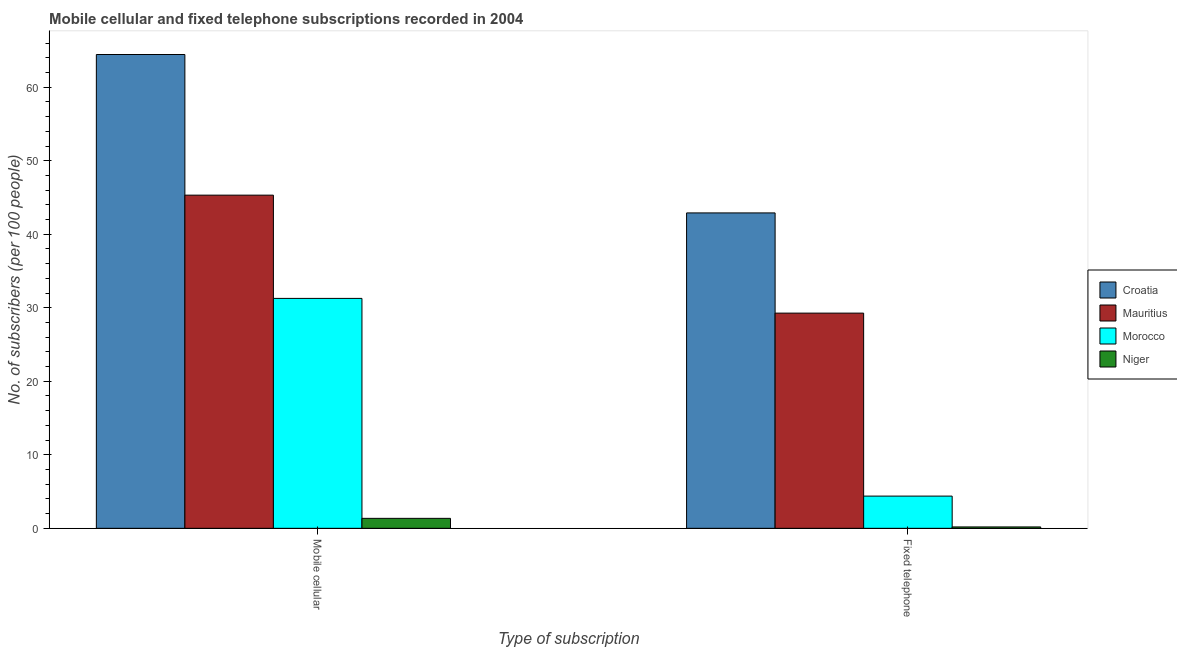How many groups of bars are there?
Your response must be concise. 2. Are the number of bars per tick equal to the number of legend labels?
Your response must be concise. Yes. How many bars are there on the 1st tick from the right?
Keep it short and to the point. 4. What is the label of the 2nd group of bars from the left?
Make the answer very short. Fixed telephone. What is the number of mobile cellular subscribers in Croatia?
Provide a short and direct response. 64.45. Across all countries, what is the maximum number of fixed telephone subscribers?
Provide a short and direct response. 42.9. Across all countries, what is the minimum number of fixed telephone subscribers?
Your answer should be compact. 0.19. In which country was the number of mobile cellular subscribers maximum?
Provide a short and direct response. Croatia. In which country was the number of fixed telephone subscribers minimum?
Your answer should be compact. Niger. What is the total number of fixed telephone subscribers in the graph?
Ensure brevity in your answer.  76.75. What is the difference between the number of fixed telephone subscribers in Croatia and that in Niger?
Your answer should be compact. 42.71. What is the difference between the number of fixed telephone subscribers in Croatia and the number of mobile cellular subscribers in Niger?
Keep it short and to the point. 41.55. What is the average number of fixed telephone subscribers per country?
Provide a short and direct response. 19.19. What is the difference between the number of fixed telephone subscribers and number of mobile cellular subscribers in Croatia?
Make the answer very short. -21.54. In how many countries, is the number of mobile cellular subscribers greater than 58 ?
Provide a succinct answer. 1. What is the ratio of the number of mobile cellular subscribers in Niger to that in Morocco?
Make the answer very short. 0.04. Is the number of mobile cellular subscribers in Croatia less than that in Niger?
Your answer should be very brief. No. What does the 1st bar from the left in Fixed telephone represents?
Make the answer very short. Croatia. What does the 3rd bar from the right in Fixed telephone represents?
Ensure brevity in your answer.  Mauritius. How many bars are there?
Offer a terse response. 8. How many countries are there in the graph?
Ensure brevity in your answer.  4. Are the values on the major ticks of Y-axis written in scientific E-notation?
Offer a very short reply. No. Does the graph contain any zero values?
Offer a terse response. No. What is the title of the graph?
Your answer should be very brief. Mobile cellular and fixed telephone subscriptions recorded in 2004. What is the label or title of the X-axis?
Provide a succinct answer. Type of subscription. What is the label or title of the Y-axis?
Ensure brevity in your answer.  No. of subscribers (per 100 people). What is the No. of subscribers (per 100 people) in Croatia in Mobile cellular?
Your answer should be compact. 64.45. What is the No. of subscribers (per 100 people) in Mauritius in Mobile cellular?
Ensure brevity in your answer.  45.32. What is the No. of subscribers (per 100 people) of Morocco in Mobile cellular?
Keep it short and to the point. 31.27. What is the No. of subscribers (per 100 people) in Niger in Mobile cellular?
Ensure brevity in your answer.  1.36. What is the No. of subscribers (per 100 people) in Croatia in Fixed telephone?
Keep it short and to the point. 42.9. What is the No. of subscribers (per 100 people) in Mauritius in Fixed telephone?
Give a very brief answer. 29.27. What is the No. of subscribers (per 100 people) in Morocco in Fixed telephone?
Your response must be concise. 4.38. What is the No. of subscribers (per 100 people) in Niger in Fixed telephone?
Give a very brief answer. 0.19. Across all Type of subscription, what is the maximum No. of subscribers (per 100 people) in Croatia?
Your answer should be very brief. 64.45. Across all Type of subscription, what is the maximum No. of subscribers (per 100 people) of Mauritius?
Your answer should be very brief. 45.32. Across all Type of subscription, what is the maximum No. of subscribers (per 100 people) in Morocco?
Keep it short and to the point. 31.27. Across all Type of subscription, what is the maximum No. of subscribers (per 100 people) of Niger?
Your answer should be compact. 1.36. Across all Type of subscription, what is the minimum No. of subscribers (per 100 people) in Croatia?
Make the answer very short. 42.9. Across all Type of subscription, what is the minimum No. of subscribers (per 100 people) of Mauritius?
Offer a very short reply. 29.27. Across all Type of subscription, what is the minimum No. of subscribers (per 100 people) in Morocco?
Provide a short and direct response. 4.38. Across all Type of subscription, what is the minimum No. of subscribers (per 100 people) of Niger?
Make the answer very short. 0.19. What is the total No. of subscribers (per 100 people) of Croatia in the graph?
Provide a succinct answer. 107.35. What is the total No. of subscribers (per 100 people) in Mauritius in the graph?
Your answer should be compact. 74.59. What is the total No. of subscribers (per 100 people) of Morocco in the graph?
Offer a very short reply. 35.66. What is the total No. of subscribers (per 100 people) in Niger in the graph?
Give a very brief answer. 1.55. What is the difference between the No. of subscribers (per 100 people) in Croatia in Mobile cellular and that in Fixed telephone?
Offer a terse response. 21.54. What is the difference between the No. of subscribers (per 100 people) in Mauritius in Mobile cellular and that in Fixed telephone?
Ensure brevity in your answer.  16.05. What is the difference between the No. of subscribers (per 100 people) of Morocco in Mobile cellular and that in Fixed telephone?
Provide a succinct answer. 26.89. What is the difference between the No. of subscribers (per 100 people) of Niger in Mobile cellular and that in Fixed telephone?
Give a very brief answer. 1.17. What is the difference between the No. of subscribers (per 100 people) in Croatia in Mobile cellular and the No. of subscribers (per 100 people) in Mauritius in Fixed telephone?
Your answer should be compact. 35.17. What is the difference between the No. of subscribers (per 100 people) in Croatia in Mobile cellular and the No. of subscribers (per 100 people) in Morocco in Fixed telephone?
Make the answer very short. 60.06. What is the difference between the No. of subscribers (per 100 people) of Croatia in Mobile cellular and the No. of subscribers (per 100 people) of Niger in Fixed telephone?
Ensure brevity in your answer.  64.26. What is the difference between the No. of subscribers (per 100 people) of Mauritius in Mobile cellular and the No. of subscribers (per 100 people) of Morocco in Fixed telephone?
Provide a succinct answer. 40.94. What is the difference between the No. of subscribers (per 100 people) in Mauritius in Mobile cellular and the No. of subscribers (per 100 people) in Niger in Fixed telephone?
Provide a succinct answer. 45.13. What is the difference between the No. of subscribers (per 100 people) in Morocco in Mobile cellular and the No. of subscribers (per 100 people) in Niger in Fixed telephone?
Provide a short and direct response. 31.08. What is the average No. of subscribers (per 100 people) in Croatia per Type of subscription?
Give a very brief answer. 53.68. What is the average No. of subscribers (per 100 people) in Mauritius per Type of subscription?
Make the answer very short. 37.3. What is the average No. of subscribers (per 100 people) of Morocco per Type of subscription?
Provide a short and direct response. 17.83. What is the average No. of subscribers (per 100 people) in Niger per Type of subscription?
Keep it short and to the point. 0.77. What is the difference between the No. of subscribers (per 100 people) of Croatia and No. of subscribers (per 100 people) of Mauritius in Mobile cellular?
Your answer should be very brief. 19.13. What is the difference between the No. of subscribers (per 100 people) in Croatia and No. of subscribers (per 100 people) in Morocco in Mobile cellular?
Your response must be concise. 33.17. What is the difference between the No. of subscribers (per 100 people) in Croatia and No. of subscribers (per 100 people) in Niger in Mobile cellular?
Make the answer very short. 63.09. What is the difference between the No. of subscribers (per 100 people) in Mauritius and No. of subscribers (per 100 people) in Morocco in Mobile cellular?
Provide a succinct answer. 14.05. What is the difference between the No. of subscribers (per 100 people) of Mauritius and No. of subscribers (per 100 people) of Niger in Mobile cellular?
Offer a very short reply. 43.96. What is the difference between the No. of subscribers (per 100 people) of Morocco and No. of subscribers (per 100 people) of Niger in Mobile cellular?
Ensure brevity in your answer.  29.92. What is the difference between the No. of subscribers (per 100 people) of Croatia and No. of subscribers (per 100 people) of Mauritius in Fixed telephone?
Provide a succinct answer. 13.63. What is the difference between the No. of subscribers (per 100 people) of Croatia and No. of subscribers (per 100 people) of Morocco in Fixed telephone?
Ensure brevity in your answer.  38.52. What is the difference between the No. of subscribers (per 100 people) of Croatia and No. of subscribers (per 100 people) of Niger in Fixed telephone?
Ensure brevity in your answer.  42.71. What is the difference between the No. of subscribers (per 100 people) in Mauritius and No. of subscribers (per 100 people) in Morocco in Fixed telephone?
Provide a succinct answer. 24.89. What is the difference between the No. of subscribers (per 100 people) in Mauritius and No. of subscribers (per 100 people) in Niger in Fixed telephone?
Offer a very short reply. 29.08. What is the difference between the No. of subscribers (per 100 people) in Morocco and No. of subscribers (per 100 people) in Niger in Fixed telephone?
Ensure brevity in your answer.  4.19. What is the ratio of the No. of subscribers (per 100 people) of Croatia in Mobile cellular to that in Fixed telephone?
Your answer should be very brief. 1.5. What is the ratio of the No. of subscribers (per 100 people) in Mauritius in Mobile cellular to that in Fixed telephone?
Provide a short and direct response. 1.55. What is the ratio of the No. of subscribers (per 100 people) in Morocco in Mobile cellular to that in Fixed telephone?
Offer a very short reply. 7.14. What is the ratio of the No. of subscribers (per 100 people) in Niger in Mobile cellular to that in Fixed telephone?
Your answer should be very brief. 7.17. What is the difference between the highest and the second highest No. of subscribers (per 100 people) in Croatia?
Your answer should be compact. 21.54. What is the difference between the highest and the second highest No. of subscribers (per 100 people) in Mauritius?
Provide a succinct answer. 16.05. What is the difference between the highest and the second highest No. of subscribers (per 100 people) in Morocco?
Your answer should be compact. 26.89. What is the difference between the highest and the second highest No. of subscribers (per 100 people) in Niger?
Make the answer very short. 1.17. What is the difference between the highest and the lowest No. of subscribers (per 100 people) in Croatia?
Your answer should be compact. 21.54. What is the difference between the highest and the lowest No. of subscribers (per 100 people) in Mauritius?
Ensure brevity in your answer.  16.05. What is the difference between the highest and the lowest No. of subscribers (per 100 people) of Morocco?
Your response must be concise. 26.89. What is the difference between the highest and the lowest No. of subscribers (per 100 people) of Niger?
Ensure brevity in your answer.  1.17. 